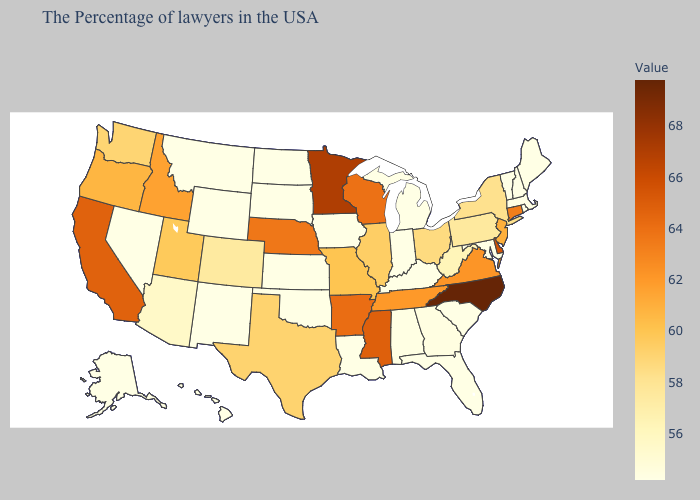Does West Virginia have the highest value in the USA?
Answer briefly. No. Which states have the lowest value in the USA?
Concise answer only. Maine, Massachusetts, Rhode Island, New Hampshire, Vermont, Maryland, South Carolina, Florida, Michigan, Kentucky, Indiana, Louisiana, Iowa, Kansas, Oklahoma, South Dakota, North Dakota, Wyoming, New Mexico, Montana, Nevada, Alaska, Hawaii. Which states have the lowest value in the MidWest?
Concise answer only. Michigan, Indiana, Iowa, Kansas, South Dakota, North Dakota. Is the legend a continuous bar?
Answer briefly. Yes. Which states have the lowest value in the USA?
Keep it brief. Maine, Massachusetts, Rhode Island, New Hampshire, Vermont, Maryland, South Carolina, Florida, Michigan, Kentucky, Indiana, Louisiana, Iowa, Kansas, Oklahoma, South Dakota, North Dakota, Wyoming, New Mexico, Montana, Nevada, Alaska, Hawaii. Which states have the highest value in the USA?
Give a very brief answer. North Carolina. Does Idaho have the lowest value in the West?
Short answer required. No. Which states hav the highest value in the South?
Answer briefly. North Carolina. Does Texas have the lowest value in the South?
Write a very short answer. No. Does Texas have the lowest value in the USA?
Concise answer only. No. 